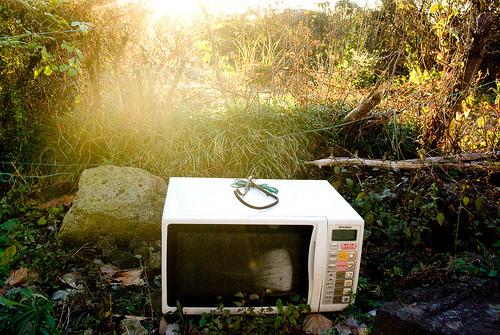Will the microwave work?
Answer briefly. No. Is the microwave on?
Quick response, please. No. Which tool is this?
Keep it brief. Microwave. What brand microwave is this?
Short answer required. Ge. Is the sun shining bright?
Be succinct. Yes. 